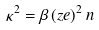<formula> <loc_0><loc_0><loc_500><loc_500>\kappa ^ { 2 } = \beta \, ( z e ) ^ { 2 } \, n</formula> 